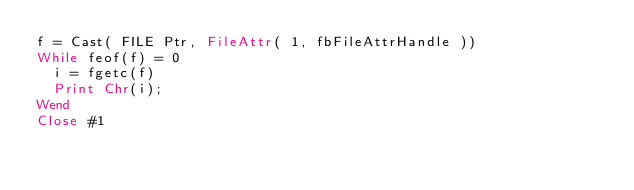<code> <loc_0><loc_0><loc_500><loc_500><_VisualBasic_>f = Cast( FILE Ptr, FileAttr( 1, fbFileAttrHandle ))
While feof(f) = 0
  i = fgetc(f)
  Print Chr(i);
Wend
Close #1
</code> 